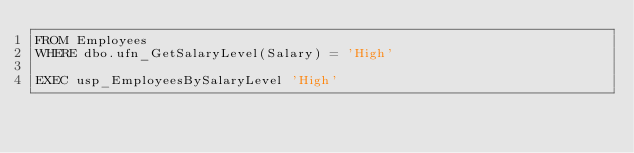<code> <loc_0><loc_0><loc_500><loc_500><_SQL_>FROM Employees
WHERE dbo.ufn_GetSalaryLevel(Salary) = 'High'

EXEC usp_EmployeesBySalaryLevel 'High'

</code> 